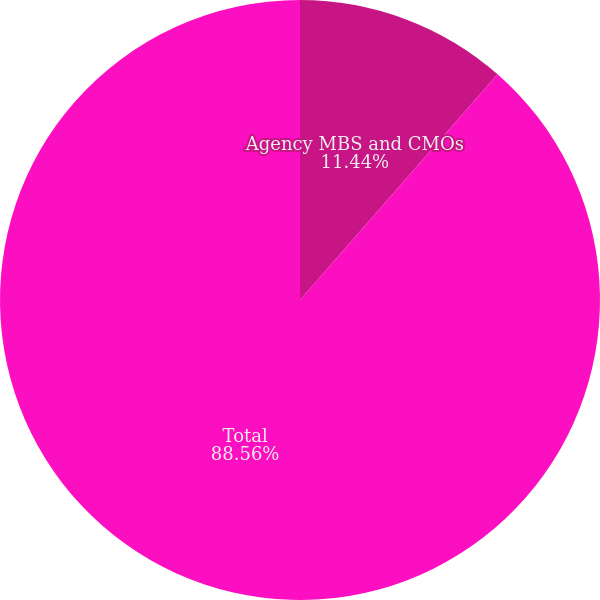Convert chart to OTSL. <chart><loc_0><loc_0><loc_500><loc_500><pie_chart><fcel>Agency MBS and CMOs<fcel>Total<nl><fcel>11.44%<fcel>88.56%<nl></chart> 